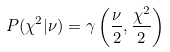Convert formula to latex. <formula><loc_0><loc_0><loc_500><loc_500>P ( \chi ^ { 2 } | \nu ) = \gamma \left ( \frac { \nu } { 2 } , \frac { \chi ^ { 2 } } { 2 } \right )</formula> 